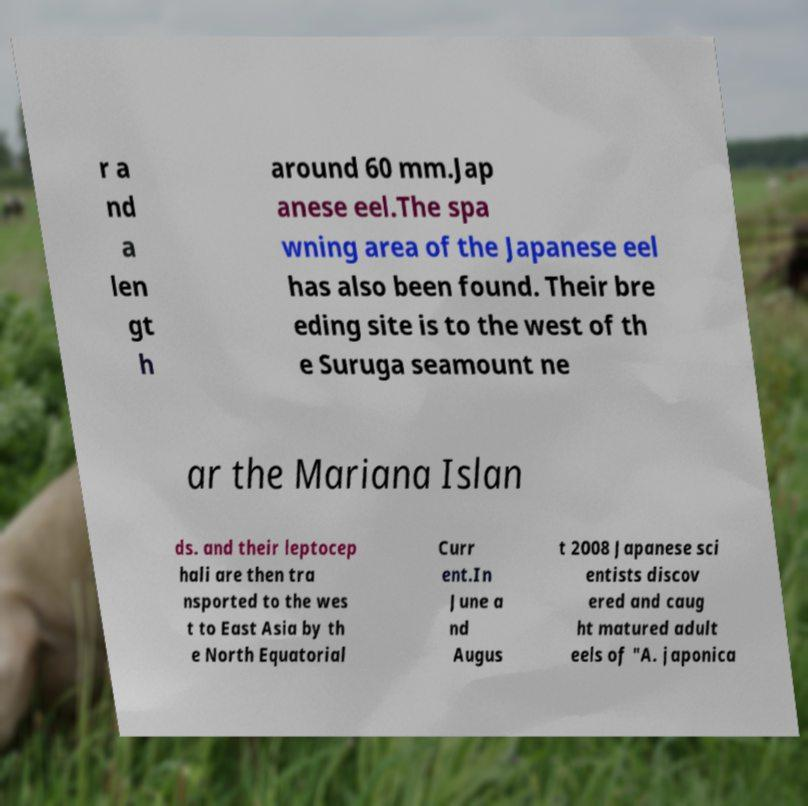Could you extract and type out the text from this image? r a nd a len gt h around 60 mm.Jap anese eel.The spa wning area of the Japanese eel has also been found. Their bre eding site is to the west of th e Suruga seamount ne ar the Mariana Islan ds. and their leptocep hali are then tra nsported to the wes t to East Asia by th e North Equatorial Curr ent.In June a nd Augus t 2008 Japanese sci entists discov ered and caug ht matured adult eels of "A. japonica 